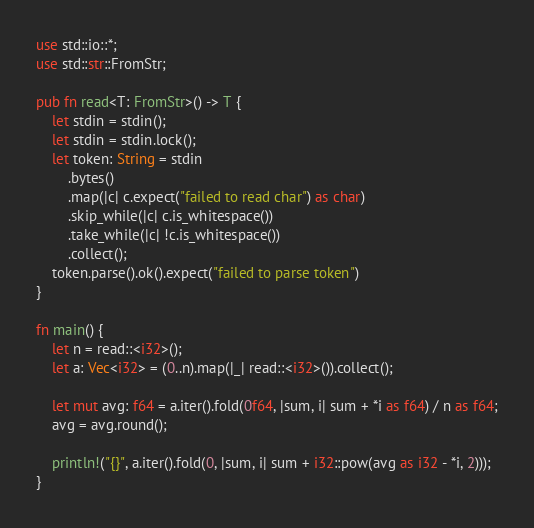<code> <loc_0><loc_0><loc_500><loc_500><_Rust_>use std::io::*;
use std::str::FromStr;

pub fn read<T: FromStr>() -> T {
    let stdin = stdin();
    let stdin = stdin.lock();
    let token: String = stdin
        .bytes()
        .map(|c| c.expect("failed to read char") as char) 
        .skip_while(|c| c.is_whitespace())
        .take_while(|c| !c.is_whitespace())
        .collect();
    token.parse().ok().expect("failed to parse token")
}

fn main() {
    let n = read::<i32>();
    let a: Vec<i32> = (0..n).map(|_| read::<i32>()).collect();

    let mut avg: f64 = a.iter().fold(0f64, |sum, i| sum + *i as f64) / n as f64;
    avg = avg.round();

    println!("{}", a.iter().fold(0, |sum, i| sum + i32::pow(avg as i32 - *i, 2)));
}
</code> 